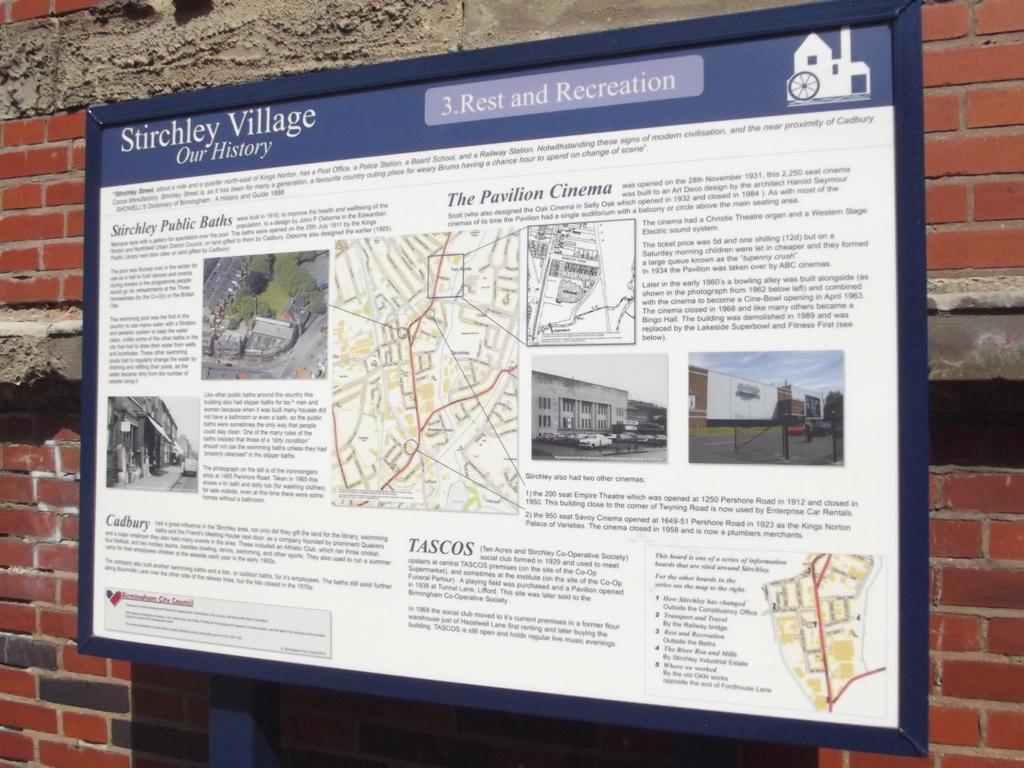Describe this image in one or two sentences. In this image, In this image, I see a board in which there is a map and few photos of the city and it also says "Stirchley Village our history". In the background I see the wall. 